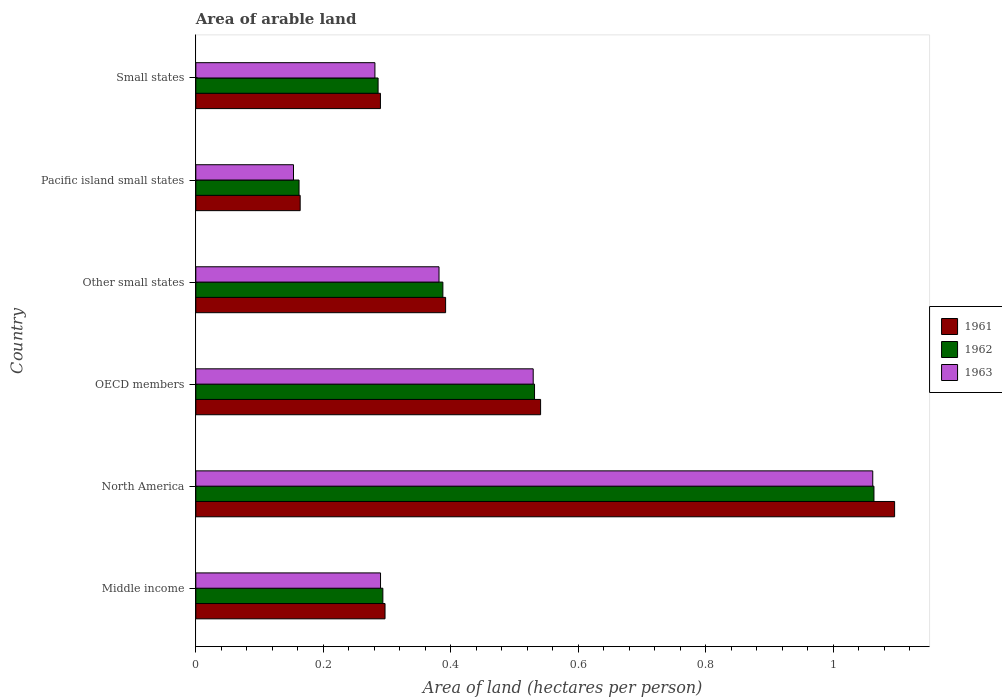How many different coloured bars are there?
Your answer should be compact. 3. How many bars are there on the 1st tick from the bottom?
Provide a succinct answer. 3. What is the label of the 2nd group of bars from the top?
Offer a very short reply. Pacific island small states. What is the total arable land in 1962 in OECD members?
Offer a very short reply. 0.53. Across all countries, what is the maximum total arable land in 1961?
Your answer should be very brief. 1.1. Across all countries, what is the minimum total arable land in 1963?
Give a very brief answer. 0.15. In which country was the total arable land in 1962 maximum?
Ensure brevity in your answer.  North America. In which country was the total arable land in 1963 minimum?
Offer a very short reply. Pacific island small states. What is the total total arable land in 1962 in the graph?
Provide a succinct answer. 2.72. What is the difference between the total arable land in 1962 in Middle income and that in North America?
Ensure brevity in your answer.  -0.77. What is the difference between the total arable land in 1963 in Other small states and the total arable land in 1962 in Small states?
Offer a terse response. 0.1. What is the average total arable land in 1962 per country?
Give a very brief answer. 0.45. What is the difference between the total arable land in 1963 and total arable land in 1961 in Pacific island small states?
Your answer should be compact. -0.01. In how many countries, is the total arable land in 1963 greater than 0.6400000000000001 hectares per person?
Your response must be concise. 1. What is the ratio of the total arable land in 1961 in Middle income to that in Pacific island small states?
Your answer should be very brief. 1.81. What is the difference between the highest and the second highest total arable land in 1963?
Provide a succinct answer. 0.53. What is the difference between the highest and the lowest total arable land in 1963?
Provide a succinct answer. 0.91. Is the sum of the total arable land in 1963 in OECD members and Pacific island small states greater than the maximum total arable land in 1962 across all countries?
Give a very brief answer. No. What does the 1st bar from the top in Pacific island small states represents?
Make the answer very short. 1963. Is it the case that in every country, the sum of the total arable land in 1961 and total arable land in 1963 is greater than the total arable land in 1962?
Offer a very short reply. Yes. How many bars are there?
Keep it short and to the point. 18. What is the difference between two consecutive major ticks on the X-axis?
Your response must be concise. 0.2. Are the values on the major ticks of X-axis written in scientific E-notation?
Keep it short and to the point. No. Does the graph contain grids?
Keep it short and to the point. No. How many legend labels are there?
Make the answer very short. 3. What is the title of the graph?
Give a very brief answer. Area of arable land. Does "2000" appear as one of the legend labels in the graph?
Ensure brevity in your answer.  No. What is the label or title of the X-axis?
Your answer should be very brief. Area of land (hectares per person). What is the label or title of the Y-axis?
Your response must be concise. Country. What is the Area of land (hectares per person) of 1961 in Middle income?
Offer a terse response. 0.3. What is the Area of land (hectares per person) of 1962 in Middle income?
Make the answer very short. 0.29. What is the Area of land (hectares per person) of 1963 in Middle income?
Make the answer very short. 0.29. What is the Area of land (hectares per person) of 1961 in North America?
Your response must be concise. 1.1. What is the Area of land (hectares per person) of 1962 in North America?
Provide a succinct answer. 1.06. What is the Area of land (hectares per person) in 1963 in North America?
Your response must be concise. 1.06. What is the Area of land (hectares per person) of 1961 in OECD members?
Ensure brevity in your answer.  0.54. What is the Area of land (hectares per person) in 1962 in OECD members?
Your answer should be compact. 0.53. What is the Area of land (hectares per person) in 1963 in OECD members?
Your response must be concise. 0.53. What is the Area of land (hectares per person) in 1961 in Other small states?
Your answer should be very brief. 0.39. What is the Area of land (hectares per person) of 1962 in Other small states?
Provide a short and direct response. 0.39. What is the Area of land (hectares per person) of 1963 in Other small states?
Your response must be concise. 0.38. What is the Area of land (hectares per person) of 1961 in Pacific island small states?
Keep it short and to the point. 0.16. What is the Area of land (hectares per person) in 1962 in Pacific island small states?
Ensure brevity in your answer.  0.16. What is the Area of land (hectares per person) of 1963 in Pacific island small states?
Provide a succinct answer. 0.15. What is the Area of land (hectares per person) of 1961 in Small states?
Offer a very short reply. 0.29. What is the Area of land (hectares per person) in 1962 in Small states?
Offer a terse response. 0.29. What is the Area of land (hectares per person) in 1963 in Small states?
Offer a very short reply. 0.28. Across all countries, what is the maximum Area of land (hectares per person) of 1961?
Your answer should be very brief. 1.1. Across all countries, what is the maximum Area of land (hectares per person) in 1962?
Ensure brevity in your answer.  1.06. Across all countries, what is the maximum Area of land (hectares per person) in 1963?
Your answer should be very brief. 1.06. Across all countries, what is the minimum Area of land (hectares per person) in 1961?
Your response must be concise. 0.16. Across all countries, what is the minimum Area of land (hectares per person) in 1962?
Your answer should be compact. 0.16. Across all countries, what is the minimum Area of land (hectares per person) of 1963?
Your answer should be compact. 0.15. What is the total Area of land (hectares per person) of 1961 in the graph?
Offer a terse response. 2.78. What is the total Area of land (hectares per person) of 1962 in the graph?
Offer a terse response. 2.72. What is the total Area of land (hectares per person) in 1963 in the graph?
Offer a terse response. 2.7. What is the difference between the Area of land (hectares per person) of 1961 in Middle income and that in North America?
Make the answer very short. -0.8. What is the difference between the Area of land (hectares per person) in 1962 in Middle income and that in North America?
Make the answer very short. -0.77. What is the difference between the Area of land (hectares per person) of 1963 in Middle income and that in North America?
Offer a very short reply. -0.77. What is the difference between the Area of land (hectares per person) of 1961 in Middle income and that in OECD members?
Your answer should be compact. -0.24. What is the difference between the Area of land (hectares per person) of 1962 in Middle income and that in OECD members?
Your response must be concise. -0.24. What is the difference between the Area of land (hectares per person) of 1963 in Middle income and that in OECD members?
Offer a terse response. -0.24. What is the difference between the Area of land (hectares per person) in 1961 in Middle income and that in Other small states?
Keep it short and to the point. -0.1. What is the difference between the Area of land (hectares per person) of 1962 in Middle income and that in Other small states?
Your answer should be compact. -0.09. What is the difference between the Area of land (hectares per person) in 1963 in Middle income and that in Other small states?
Offer a terse response. -0.09. What is the difference between the Area of land (hectares per person) in 1961 in Middle income and that in Pacific island small states?
Provide a succinct answer. 0.13. What is the difference between the Area of land (hectares per person) of 1962 in Middle income and that in Pacific island small states?
Offer a very short reply. 0.13. What is the difference between the Area of land (hectares per person) in 1963 in Middle income and that in Pacific island small states?
Your answer should be compact. 0.14. What is the difference between the Area of land (hectares per person) in 1961 in Middle income and that in Small states?
Ensure brevity in your answer.  0.01. What is the difference between the Area of land (hectares per person) of 1962 in Middle income and that in Small states?
Your answer should be compact. 0.01. What is the difference between the Area of land (hectares per person) in 1963 in Middle income and that in Small states?
Your answer should be compact. 0.01. What is the difference between the Area of land (hectares per person) in 1961 in North America and that in OECD members?
Your answer should be very brief. 0.56. What is the difference between the Area of land (hectares per person) in 1962 in North America and that in OECD members?
Ensure brevity in your answer.  0.53. What is the difference between the Area of land (hectares per person) of 1963 in North America and that in OECD members?
Give a very brief answer. 0.53. What is the difference between the Area of land (hectares per person) of 1961 in North America and that in Other small states?
Your answer should be compact. 0.7. What is the difference between the Area of land (hectares per person) of 1962 in North America and that in Other small states?
Your answer should be compact. 0.68. What is the difference between the Area of land (hectares per person) of 1963 in North America and that in Other small states?
Keep it short and to the point. 0.68. What is the difference between the Area of land (hectares per person) of 1961 in North America and that in Pacific island small states?
Provide a short and direct response. 0.93. What is the difference between the Area of land (hectares per person) in 1962 in North America and that in Pacific island small states?
Provide a succinct answer. 0.9. What is the difference between the Area of land (hectares per person) of 1963 in North America and that in Pacific island small states?
Offer a very short reply. 0.91. What is the difference between the Area of land (hectares per person) in 1961 in North America and that in Small states?
Offer a terse response. 0.81. What is the difference between the Area of land (hectares per person) of 1962 in North America and that in Small states?
Give a very brief answer. 0.78. What is the difference between the Area of land (hectares per person) in 1963 in North America and that in Small states?
Your answer should be very brief. 0.78. What is the difference between the Area of land (hectares per person) of 1961 in OECD members and that in Other small states?
Your response must be concise. 0.15. What is the difference between the Area of land (hectares per person) in 1962 in OECD members and that in Other small states?
Provide a short and direct response. 0.14. What is the difference between the Area of land (hectares per person) of 1963 in OECD members and that in Other small states?
Ensure brevity in your answer.  0.15. What is the difference between the Area of land (hectares per person) in 1961 in OECD members and that in Pacific island small states?
Make the answer very short. 0.38. What is the difference between the Area of land (hectares per person) of 1962 in OECD members and that in Pacific island small states?
Ensure brevity in your answer.  0.37. What is the difference between the Area of land (hectares per person) of 1963 in OECD members and that in Pacific island small states?
Offer a terse response. 0.38. What is the difference between the Area of land (hectares per person) of 1961 in OECD members and that in Small states?
Your answer should be compact. 0.25. What is the difference between the Area of land (hectares per person) in 1962 in OECD members and that in Small states?
Your answer should be compact. 0.25. What is the difference between the Area of land (hectares per person) in 1963 in OECD members and that in Small states?
Your answer should be compact. 0.25. What is the difference between the Area of land (hectares per person) in 1961 in Other small states and that in Pacific island small states?
Provide a succinct answer. 0.23. What is the difference between the Area of land (hectares per person) of 1962 in Other small states and that in Pacific island small states?
Give a very brief answer. 0.23. What is the difference between the Area of land (hectares per person) in 1963 in Other small states and that in Pacific island small states?
Your answer should be compact. 0.23. What is the difference between the Area of land (hectares per person) in 1961 in Other small states and that in Small states?
Your response must be concise. 0.1. What is the difference between the Area of land (hectares per person) in 1962 in Other small states and that in Small states?
Give a very brief answer. 0.1. What is the difference between the Area of land (hectares per person) of 1963 in Other small states and that in Small states?
Give a very brief answer. 0.1. What is the difference between the Area of land (hectares per person) of 1961 in Pacific island small states and that in Small states?
Your answer should be compact. -0.13. What is the difference between the Area of land (hectares per person) of 1962 in Pacific island small states and that in Small states?
Offer a very short reply. -0.12. What is the difference between the Area of land (hectares per person) of 1963 in Pacific island small states and that in Small states?
Give a very brief answer. -0.13. What is the difference between the Area of land (hectares per person) in 1961 in Middle income and the Area of land (hectares per person) in 1962 in North America?
Your response must be concise. -0.77. What is the difference between the Area of land (hectares per person) in 1961 in Middle income and the Area of land (hectares per person) in 1963 in North America?
Ensure brevity in your answer.  -0.77. What is the difference between the Area of land (hectares per person) of 1962 in Middle income and the Area of land (hectares per person) of 1963 in North America?
Keep it short and to the point. -0.77. What is the difference between the Area of land (hectares per person) in 1961 in Middle income and the Area of land (hectares per person) in 1962 in OECD members?
Offer a terse response. -0.23. What is the difference between the Area of land (hectares per person) in 1961 in Middle income and the Area of land (hectares per person) in 1963 in OECD members?
Provide a short and direct response. -0.23. What is the difference between the Area of land (hectares per person) of 1962 in Middle income and the Area of land (hectares per person) of 1963 in OECD members?
Ensure brevity in your answer.  -0.24. What is the difference between the Area of land (hectares per person) in 1961 in Middle income and the Area of land (hectares per person) in 1962 in Other small states?
Provide a succinct answer. -0.09. What is the difference between the Area of land (hectares per person) in 1961 in Middle income and the Area of land (hectares per person) in 1963 in Other small states?
Give a very brief answer. -0.08. What is the difference between the Area of land (hectares per person) of 1962 in Middle income and the Area of land (hectares per person) of 1963 in Other small states?
Give a very brief answer. -0.09. What is the difference between the Area of land (hectares per person) in 1961 in Middle income and the Area of land (hectares per person) in 1962 in Pacific island small states?
Provide a succinct answer. 0.13. What is the difference between the Area of land (hectares per person) in 1961 in Middle income and the Area of land (hectares per person) in 1963 in Pacific island small states?
Your response must be concise. 0.14. What is the difference between the Area of land (hectares per person) in 1962 in Middle income and the Area of land (hectares per person) in 1963 in Pacific island small states?
Ensure brevity in your answer.  0.14. What is the difference between the Area of land (hectares per person) in 1961 in Middle income and the Area of land (hectares per person) in 1962 in Small states?
Provide a short and direct response. 0.01. What is the difference between the Area of land (hectares per person) of 1961 in Middle income and the Area of land (hectares per person) of 1963 in Small states?
Give a very brief answer. 0.02. What is the difference between the Area of land (hectares per person) in 1962 in Middle income and the Area of land (hectares per person) in 1963 in Small states?
Make the answer very short. 0.01. What is the difference between the Area of land (hectares per person) of 1961 in North America and the Area of land (hectares per person) of 1962 in OECD members?
Provide a short and direct response. 0.56. What is the difference between the Area of land (hectares per person) in 1961 in North America and the Area of land (hectares per person) in 1963 in OECD members?
Ensure brevity in your answer.  0.57. What is the difference between the Area of land (hectares per person) in 1962 in North America and the Area of land (hectares per person) in 1963 in OECD members?
Your answer should be very brief. 0.53. What is the difference between the Area of land (hectares per person) of 1961 in North America and the Area of land (hectares per person) of 1962 in Other small states?
Your answer should be very brief. 0.71. What is the difference between the Area of land (hectares per person) of 1961 in North America and the Area of land (hectares per person) of 1963 in Other small states?
Provide a succinct answer. 0.71. What is the difference between the Area of land (hectares per person) of 1962 in North America and the Area of land (hectares per person) of 1963 in Other small states?
Your answer should be very brief. 0.68. What is the difference between the Area of land (hectares per person) in 1961 in North America and the Area of land (hectares per person) in 1962 in Pacific island small states?
Offer a terse response. 0.93. What is the difference between the Area of land (hectares per person) of 1961 in North America and the Area of land (hectares per person) of 1963 in Pacific island small states?
Your answer should be very brief. 0.94. What is the difference between the Area of land (hectares per person) in 1962 in North America and the Area of land (hectares per person) in 1963 in Pacific island small states?
Your answer should be compact. 0.91. What is the difference between the Area of land (hectares per person) in 1961 in North America and the Area of land (hectares per person) in 1962 in Small states?
Your answer should be very brief. 0.81. What is the difference between the Area of land (hectares per person) of 1961 in North America and the Area of land (hectares per person) of 1963 in Small states?
Ensure brevity in your answer.  0.82. What is the difference between the Area of land (hectares per person) in 1962 in North America and the Area of land (hectares per person) in 1963 in Small states?
Keep it short and to the point. 0.78. What is the difference between the Area of land (hectares per person) in 1961 in OECD members and the Area of land (hectares per person) in 1962 in Other small states?
Keep it short and to the point. 0.15. What is the difference between the Area of land (hectares per person) in 1961 in OECD members and the Area of land (hectares per person) in 1963 in Other small states?
Offer a terse response. 0.16. What is the difference between the Area of land (hectares per person) of 1962 in OECD members and the Area of land (hectares per person) of 1963 in Other small states?
Keep it short and to the point. 0.15. What is the difference between the Area of land (hectares per person) of 1961 in OECD members and the Area of land (hectares per person) of 1962 in Pacific island small states?
Offer a terse response. 0.38. What is the difference between the Area of land (hectares per person) of 1961 in OECD members and the Area of land (hectares per person) of 1963 in Pacific island small states?
Offer a terse response. 0.39. What is the difference between the Area of land (hectares per person) of 1962 in OECD members and the Area of land (hectares per person) of 1963 in Pacific island small states?
Make the answer very short. 0.38. What is the difference between the Area of land (hectares per person) in 1961 in OECD members and the Area of land (hectares per person) in 1962 in Small states?
Give a very brief answer. 0.25. What is the difference between the Area of land (hectares per person) in 1961 in OECD members and the Area of land (hectares per person) in 1963 in Small states?
Ensure brevity in your answer.  0.26. What is the difference between the Area of land (hectares per person) of 1962 in OECD members and the Area of land (hectares per person) of 1963 in Small states?
Make the answer very short. 0.25. What is the difference between the Area of land (hectares per person) of 1961 in Other small states and the Area of land (hectares per person) of 1962 in Pacific island small states?
Provide a short and direct response. 0.23. What is the difference between the Area of land (hectares per person) in 1961 in Other small states and the Area of land (hectares per person) in 1963 in Pacific island small states?
Your response must be concise. 0.24. What is the difference between the Area of land (hectares per person) of 1962 in Other small states and the Area of land (hectares per person) of 1963 in Pacific island small states?
Make the answer very short. 0.23. What is the difference between the Area of land (hectares per person) in 1961 in Other small states and the Area of land (hectares per person) in 1962 in Small states?
Give a very brief answer. 0.11. What is the difference between the Area of land (hectares per person) of 1961 in Other small states and the Area of land (hectares per person) of 1963 in Small states?
Provide a succinct answer. 0.11. What is the difference between the Area of land (hectares per person) in 1962 in Other small states and the Area of land (hectares per person) in 1963 in Small states?
Provide a short and direct response. 0.11. What is the difference between the Area of land (hectares per person) of 1961 in Pacific island small states and the Area of land (hectares per person) of 1962 in Small states?
Provide a succinct answer. -0.12. What is the difference between the Area of land (hectares per person) of 1961 in Pacific island small states and the Area of land (hectares per person) of 1963 in Small states?
Your response must be concise. -0.12. What is the difference between the Area of land (hectares per person) in 1962 in Pacific island small states and the Area of land (hectares per person) in 1963 in Small states?
Give a very brief answer. -0.12. What is the average Area of land (hectares per person) in 1961 per country?
Your response must be concise. 0.46. What is the average Area of land (hectares per person) of 1962 per country?
Provide a short and direct response. 0.45. What is the average Area of land (hectares per person) of 1963 per country?
Keep it short and to the point. 0.45. What is the difference between the Area of land (hectares per person) in 1961 and Area of land (hectares per person) in 1962 in Middle income?
Your answer should be very brief. 0. What is the difference between the Area of land (hectares per person) in 1961 and Area of land (hectares per person) in 1963 in Middle income?
Your answer should be compact. 0.01. What is the difference between the Area of land (hectares per person) in 1962 and Area of land (hectares per person) in 1963 in Middle income?
Ensure brevity in your answer.  0. What is the difference between the Area of land (hectares per person) of 1961 and Area of land (hectares per person) of 1962 in North America?
Provide a short and direct response. 0.03. What is the difference between the Area of land (hectares per person) in 1961 and Area of land (hectares per person) in 1963 in North America?
Keep it short and to the point. 0.03. What is the difference between the Area of land (hectares per person) of 1962 and Area of land (hectares per person) of 1963 in North America?
Make the answer very short. 0. What is the difference between the Area of land (hectares per person) in 1961 and Area of land (hectares per person) in 1962 in OECD members?
Offer a terse response. 0.01. What is the difference between the Area of land (hectares per person) of 1961 and Area of land (hectares per person) of 1963 in OECD members?
Keep it short and to the point. 0.01. What is the difference between the Area of land (hectares per person) of 1962 and Area of land (hectares per person) of 1963 in OECD members?
Provide a short and direct response. 0. What is the difference between the Area of land (hectares per person) of 1961 and Area of land (hectares per person) of 1962 in Other small states?
Offer a terse response. 0. What is the difference between the Area of land (hectares per person) of 1961 and Area of land (hectares per person) of 1963 in Other small states?
Make the answer very short. 0.01. What is the difference between the Area of land (hectares per person) of 1962 and Area of land (hectares per person) of 1963 in Other small states?
Provide a succinct answer. 0.01. What is the difference between the Area of land (hectares per person) of 1961 and Area of land (hectares per person) of 1962 in Pacific island small states?
Ensure brevity in your answer.  0. What is the difference between the Area of land (hectares per person) in 1961 and Area of land (hectares per person) in 1963 in Pacific island small states?
Provide a succinct answer. 0.01. What is the difference between the Area of land (hectares per person) of 1962 and Area of land (hectares per person) of 1963 in Pacific island small states?
Offer a very short reply. 0.01. What is the difference between the Area of land (hectares per person) of 1961 and Area of land (hectares per person) of 1962 in Small states?
Your answer should be very brief. 0. What is the difference between the Area of land (hectares per person) of 1961 and Area of land (hectares per person) of 1963 in Small states?
Offer a terse response. 0.01. What is the difference between the Area of land (hectares per person) in 1962 and Area of land (hectares per person) in 1963 in Small states?
Your response must be concise. 0.01. What is the ratio of the Area of land (hectares per person) in 1961 in Middle income to that in North America?
Ensure brevity in your answer.  0.27. What is the ratio of the Area of land (hectares per person) in 1962 in Middle income to that in North America?
Provide a short and direct response. 0.28. What is the ratio of the Area of land (hectares per person) of 1963 in Middle income to that in North America?
Offer a very short reply. 0.27. What is the ratio of the Area of land (hectares per person) in 1961 in Middle income to that in OECD members?
Offer a very short reply. 0.55. What is the ratio of the Area of land (hectares per person) of 1962 in Middle income to that in OECD members?
Give a very brief answer. 0.55. What is the ratio of the Area of land (hectares per person) of 1963 in Middle income to that in OECD members?
Make the answer very short. 0.55. What is the ratio of the Area of land (hectares per person) of 1961 in Middle income to that in Other small states?
Your answer should be very brief. 0.76. What is the ratio of the Area of land (hectares per person) of 1962 in Middle income to that in Other small states?
Your response must be concise. 0.76. What is the ratio of the Area of land (hectares per person) in 1963 in Middle income to that in Other small states?
Provide a short and direct response. 0.76. What is the ratio of the Area of land (hectares per person) of 1961 in Middle income to that in Pacific island small states?
Keep it short and to the point. 1.81. What is the ratio of the Area of land (hectares per person) of 1962 in Middle income to that in Pacific island small states?
Provide a succinct answer. 1.81. What is the ratio of the Area of land (hectares per person) in 1963 in Middle income to that in Pacific island small states?
Ensure brevity in your answer.  1.89. What is the ratio of the Area of land (hectares per person) in 1961 in Middle income to that in Small states?
Keep it short and to the point. 1.02. What is the ratio of the Area of land (hectares per person) of 1962 in Middle income to that in Small states?
Give a very brief answer. 1.03. What is the ratio of the Area of land (hectares per person) in 1963 in Middle income to that in Small states?
Make the answer very short. 1.03. What is the ratio of the Area of land (hectares per person) of 1961 in North America to that in OECD members?
Offer a very short reply. 2.03. What is the ratio of the Area of land (hectares per person) in 1962 in North America to that in OECD members?
Provide a short and direct response. 2. What is the ratio of the Area of land (hectares per person) in 1963 in North America to that in OECD members?
Your answer should be very brief. 2.01. What is the ratio of the Area of land (hectares per person) in 1961 in North America to that in Other small states?
Your answer should be very brief. 2.8. What is the ratio of the Area of land (hectares per person) in 1962 in North America to that in Other small states?
Ensure brevity in your answer.  2.75. What is the ratio of the Area of land (hectares per person) of 1963 in North America to that in Other small states?
Ensure brevity in your answer.  2.78. What is the ratio of the Area of land (hectares per person) of 1961 in North America to that in Pacific island small states?
Offer a very short reply. 6.7. What is the ratio of the Area of land (hectares per person) in 1962 in North America to that in Pacific island small states?
Your answer should be compact. 6.57. What is the ratio of the Area of land (hectares per person) of 1963 in North America to that in Pacific island small states?
Provide a short and direct response. 6.93. What is the ratio of the Area of land (hectares per person) in 1961 in North America to that in Small states?
Your answer should be very brief. 3.79. What is the ratio of the Area of land (hectares per person) of 1962 in North America to that in Small states?
Offer a terse response. 3.72. What is the ratio of the Area of land (hectares per person) in 1963 in North America to that in Small states?
Provide a short and direct response. 3.78. What is the ratio of the Area of land (hectares per person) of 1961 in OECD members to that in Other small states?
Your response must be concise. 1.38. What is the ratio of the Area of land (hectares per person) of 1962 in OECD members to that in Other small states?
Your response must be concise. 1.37. What is the ratio of the Area of land (hectares per person) in 1963 in OECD members to that in Other small states?
Offer a very short reply. 1.39. What is the ratio of the Area of land (hectares per person) in 1961 in OECD members to that in Pacific island small states?
Provide a short and direct response. 3.3. What is the ratio of the Area of land (hectares per person) of 1962 in OECD members to that in Pacific island small states?
Your answer should be very brief. 3.28. What is the ratio of the Area of land (hectares per person) in 1963 in OECD members to that in Pacific island small states?
Ensure brevity in your answer.  3.45. What is the ratio of the Area of land (hectares per person) of 1961 in OECD members to that in Small states?
Offer a very short reply. 1.87. What is the ratio of the Area of land (hectares per person) in 1962 in OECD members to that in Small states?
Your answer should be compact. 1.86. What is the ratio of the Area of land (hectares per person) in 1963 in OECD members to that in Small states?
Ensure brevity in your answer.  1.88. What is the ratio of the Area of land (hectares per person) of 1961 in Other small states to that in Pacific island small states?
Make the answer very short. 2.39. What is the ratio of the Area of land (hectares per person) of 1962 in Other small states to that in Pacific island small states?
Offer a terse response. 2.39. What is the ratio of the Area of land (hectares per person) in 1963 in Other small states to that in Pacific island small states?
Offer a terse response. 2.49. What is the ratio of the Area of land (hectares per person) in 1961 in Other small states to that in Small states?
Keep it short and to the point. 1.35. What is the ratio of the Area of land (hectares per person) in 1962 in Other small states to that in Small states?
Keep it short and to the point. 1.36. What is the ratio of the Area of land (hectares per person) in 1963 in Other small states to that in Small states?
Make the answer very short. 1.36. What is the ratio of the Area of land (hectares per person) of 1961 in Pacific island small states to that in Small states?
Ensure brevity in your answer.  0.57. What is the ratio of the Area of land (hectares per person) of 1962 in Pacific island small states to that in Small states?
Give a very brief answer. 0.57. What is the ratio of the Area of land (hectares per person) of 1963 in Pacific island small states to that in Small states?
Your answer should be compact. 0.55. What is the difference between the highest and the second highest Area of land (hectares per person) in 1961?
Offer a terse response. 0.56. What is the difference between the highest and the second highest Area of land (hectares per person) of 1962?
Your response must be concise. 0.53. What is the difference between the highest and the second highest Area of land (hectares per person) of 1963?
Your answer should be compact. 0.53. What is the difference between the highest and the lowest Area of land (hectares per person) of 1961?
Give a very brief answer. 0.93. What is the difference between the highest and the lowest Area of land (hectares per person) in 1962?
Your answer should be compact. 0.9. What is the difference between the highest and the lowest Area of land (hectares per person) of 1963?
Ensure brevity in your answer.  0.91. 